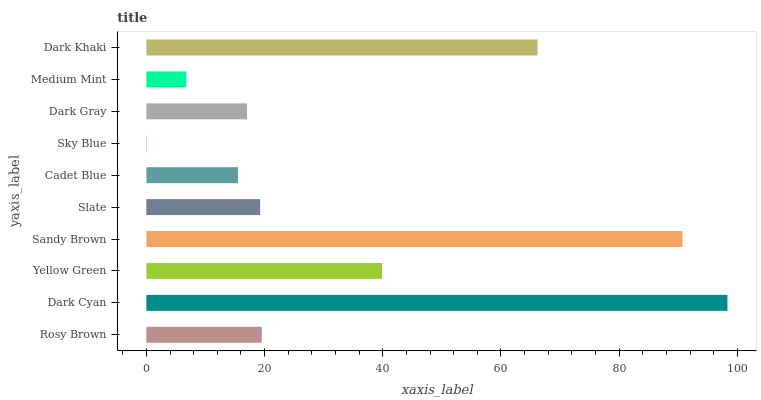Is Sky Blue the minimum?
Answer yes or no. Yes. Is Dark Cyan the maximum?
Answer yes or no. Yes. Is Yellow Green the minimum?
Answer yes or no. No. Is Yellow Green the maximum?
Answer yes or no. No. Is Dark Cyan greater than Yellow Green?
Answer yes or no. Yes. Is Yellow Green less than Dark Cyan?
Answer yes or no. Yes. Is Yellow Green greater than Dark Cyan?
Answer yes or no. No. Is Dark Cyan less than Yellow Green?
Answer yes or no. No. Is Rosy Brown the high median?
Answer yes or no. Yes. Is Slate the low median?
Answer yes or no. Yes. Is Dark Cyan the high median?
Answer yes or no. No. Is Dark Cyan the low median?
Answer yes or no. No. 